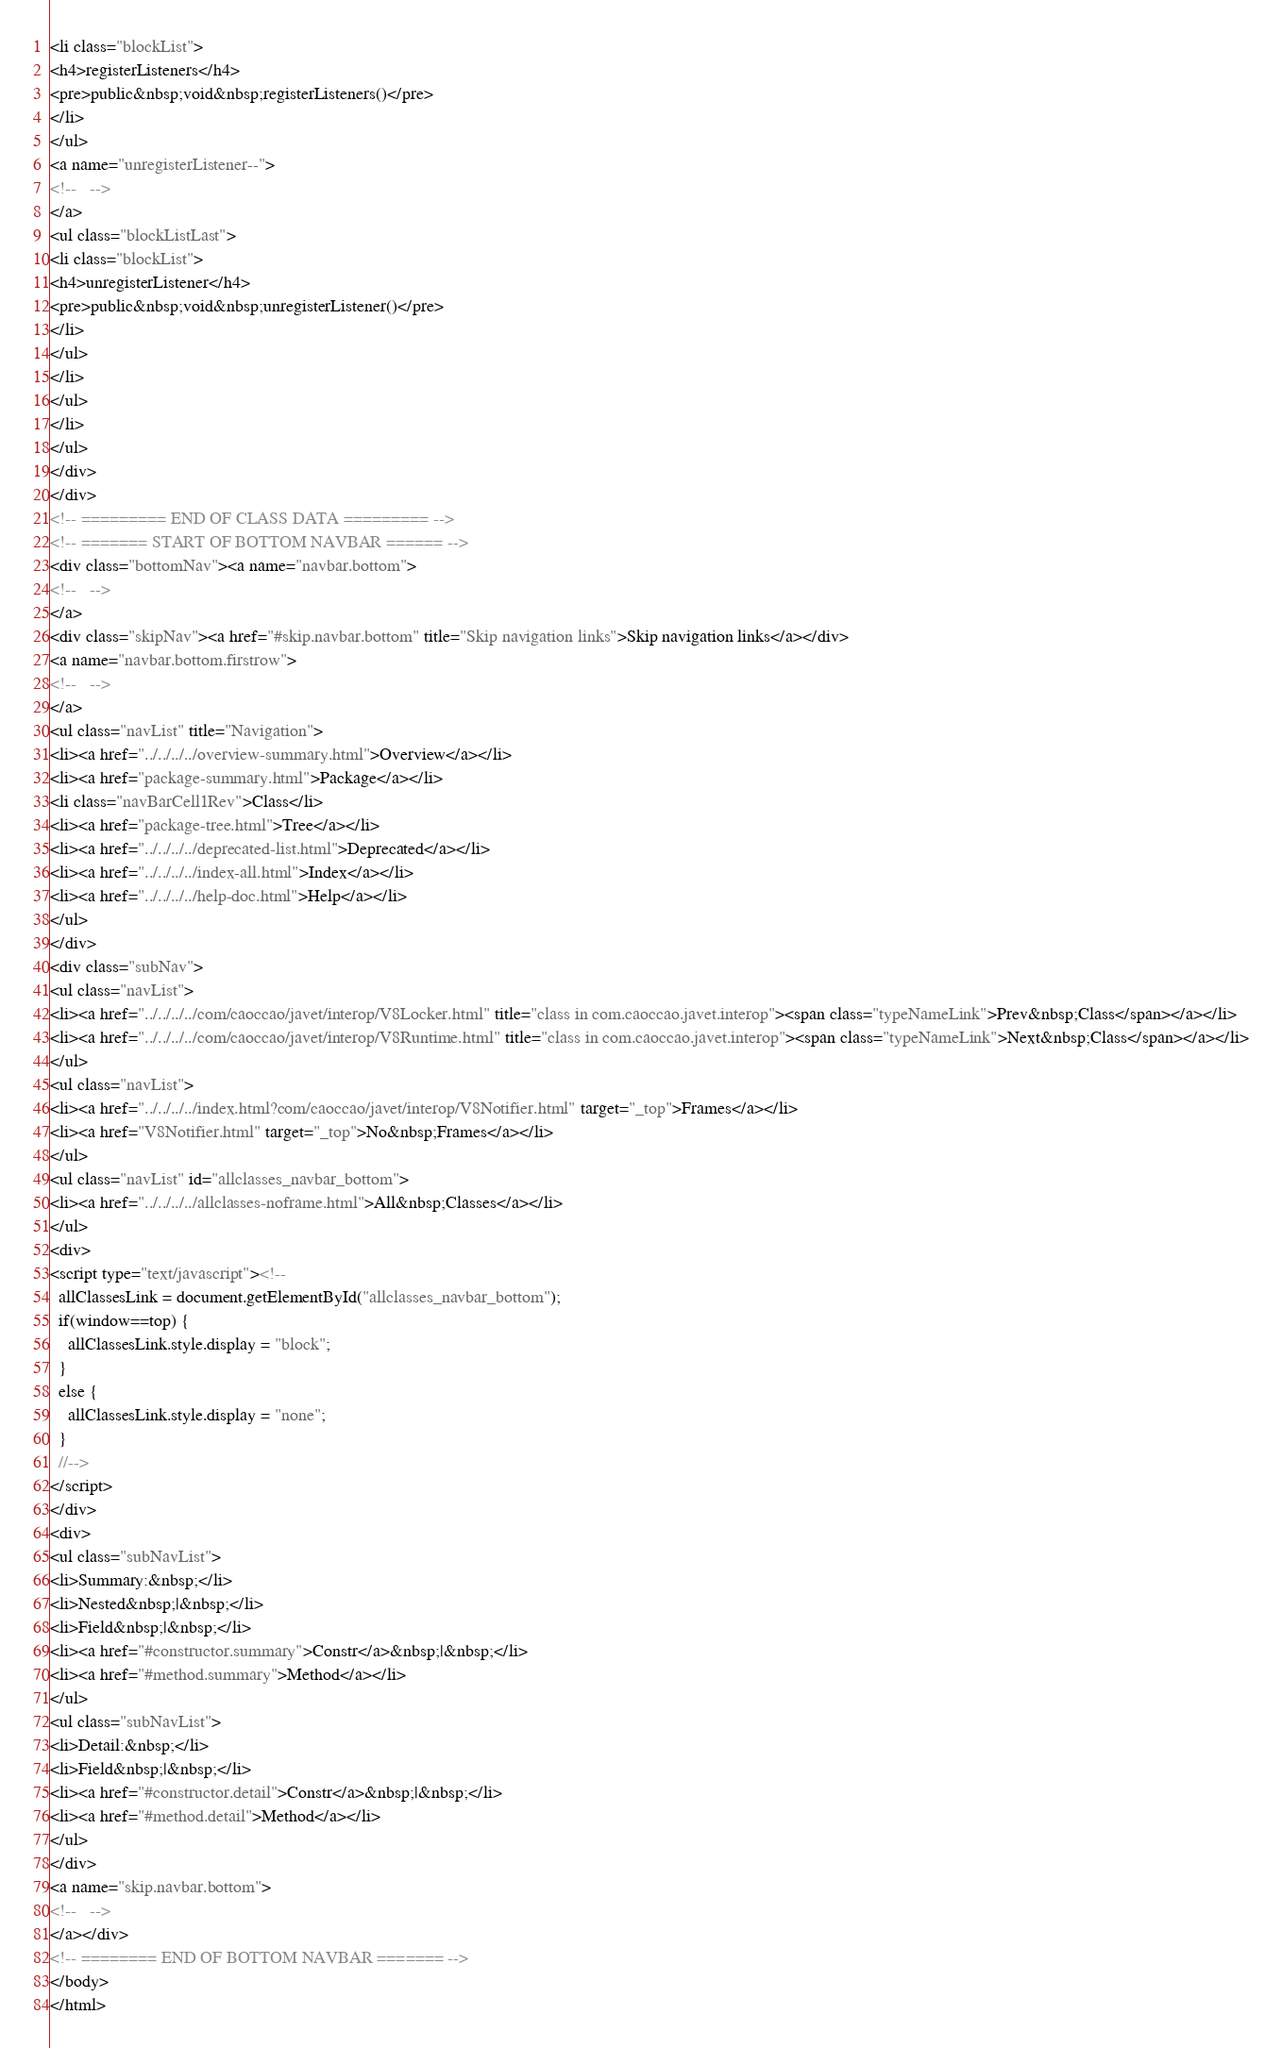Convert code to text. <code><loc_0><loc_0><loc_500><loc_500><_HTML_><li class="blockList">
<h4>registerListeners</h4>
<pre>public&nbsp;void&nbsp;registerListeners()</pre>
</li>
</ul>
<a name="unregisterListener--">
<!--   -->
</a>
<ul class="blockListLast">
<li class="blockList">
<h4>unregisterListener</h4>
<pre>public&nbsp;void&nbsp;unregisterListener()</pre>
</li>
</ul>
</li>
</ul>
</li>
</ul>
</div>
</div>
<!-- ========= END OF CLASS DATA ========= -->
<!-- ======= START OF BOTTOM NAVBAR ====== -->
<div class="bottomNav"><a name="navbar.bottom">
<!--   -->
</a>
<div class="skipNav"><a href="#skip.navbar.bottom" title="Skip navigation links">Skip navigation links</a></div>
<a name="navbar.bottom.firstrow">
<!--   -->
</a>
<ul class="navList" title="Navigation">
<li><a href="../../../../overview-summary.html">Overview</a></li>
<li><a href="package-summary.html">Package</a></li>
<li class="navBarCell1Rev">Class</li>
<li><a href="package-tree.html">Tree</a></li>
<li><a href="../../../../deprecated-list.html">Deprecated</a></li>
<li><a href="../../../../index-all.html">Index</a></li>
<li><a href="../../../../help-doc.html">Help</a></li>
</ul>
</div>
<div class="subNav">
<ul class="navList">
<li><a href="../../../../com/caoccao/javet/interop/V8Locker.html" title="class in com.caoccao.javet.interop"><span class="typeNameLink">Prev&nbsp;Class</span></a></li>
<li><a href="../../../../com/caoccao/javet/interop/V8Runtime.html" title="class in com.caoccao.javet.interop"><span class="typeNameLink">Next&nbsp;Class</span></a></li>
</ul>
<ul class="navList">
<li><a href="../../../../index.html?com/caoccao/javet/interop/V8Notifier.html" target="_top">Frames</a></li>
<li><a href="V8Notifier.html" target="_top">No&nbsp;Frames</a></li>
</ul>
<ul class="navList" id="allclasses_navbar_bottom">
<li><a href="../../../../allclasses-noframe.html">All&nbsp;Classes</a></li>
</ul>
<div>
<script type="text/javascript"><!--
  allClassesLink = document.getElementById("allclasses_navbar_bottom");
  if(window==top) {
    allClassesLink.style.display = "block";
  }
  else {
    allClassesLink.style.display = "none";
  }
  //-->
</script>
</div>
<div>
<ul class="subNavList">
<li>Summary:&nbsp;</li>
<li>Nested&nbsp;|&nbsp;</li>
<li>Field&nbsp;|&nbsp;</li>
<li><a href="#constructor.summary">Constr</a>&nbsp;|&nbsp;</li>
<li><a href="#method.summary">Method</a></li>
</ul>
<ul class="subNavList">
<li>Detail:&nbsp;</li>
<li>Field&nbsp;|&nbsp;</li>
<li><a href="#constructor.detail">Constr</a>&nbsp;|&nbsp;</li>
<li><a href="#method.detail">Method</a></li>
</ul>
</div>
<a name="skip.navbar.bottom">
<!--   -->
</a></div>
<!-- ======== END OF BOTTOM NAVBAR ======= -->
</body>
</html>
</code> 